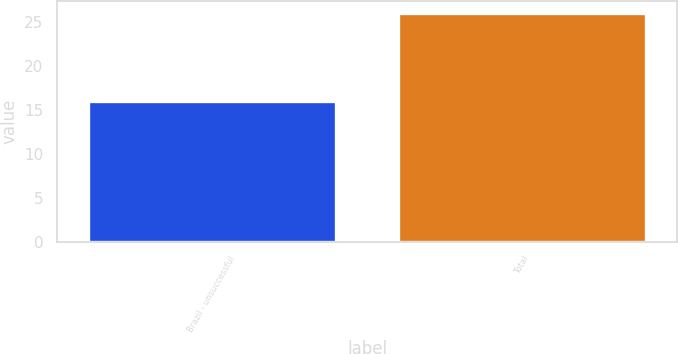Convert chart. <chart><loc_0><loc_0><loc_500><loc_500><bar_chart><fcel>Brazil - unsuccessful<fcel>Total<nl><fcel>16<fcel>26<nl></chart> 